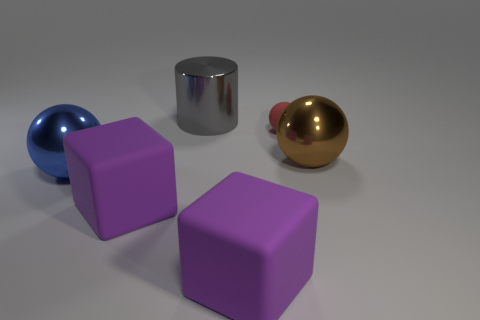Add 2 big metallic balls. How many objects exist? 8 Add 1 large brown things. How many large brown things exist? 2 Subtract 0 brown cylinders. How many objects are left? 6 Subtract all blocks. How many objects are left? 4 Subtract all tiny purple metallic blocks. Subtract all tiny rubber spheres. How many objects are left? 5 Add 4 brown balls. How many brown balls are left? 5 